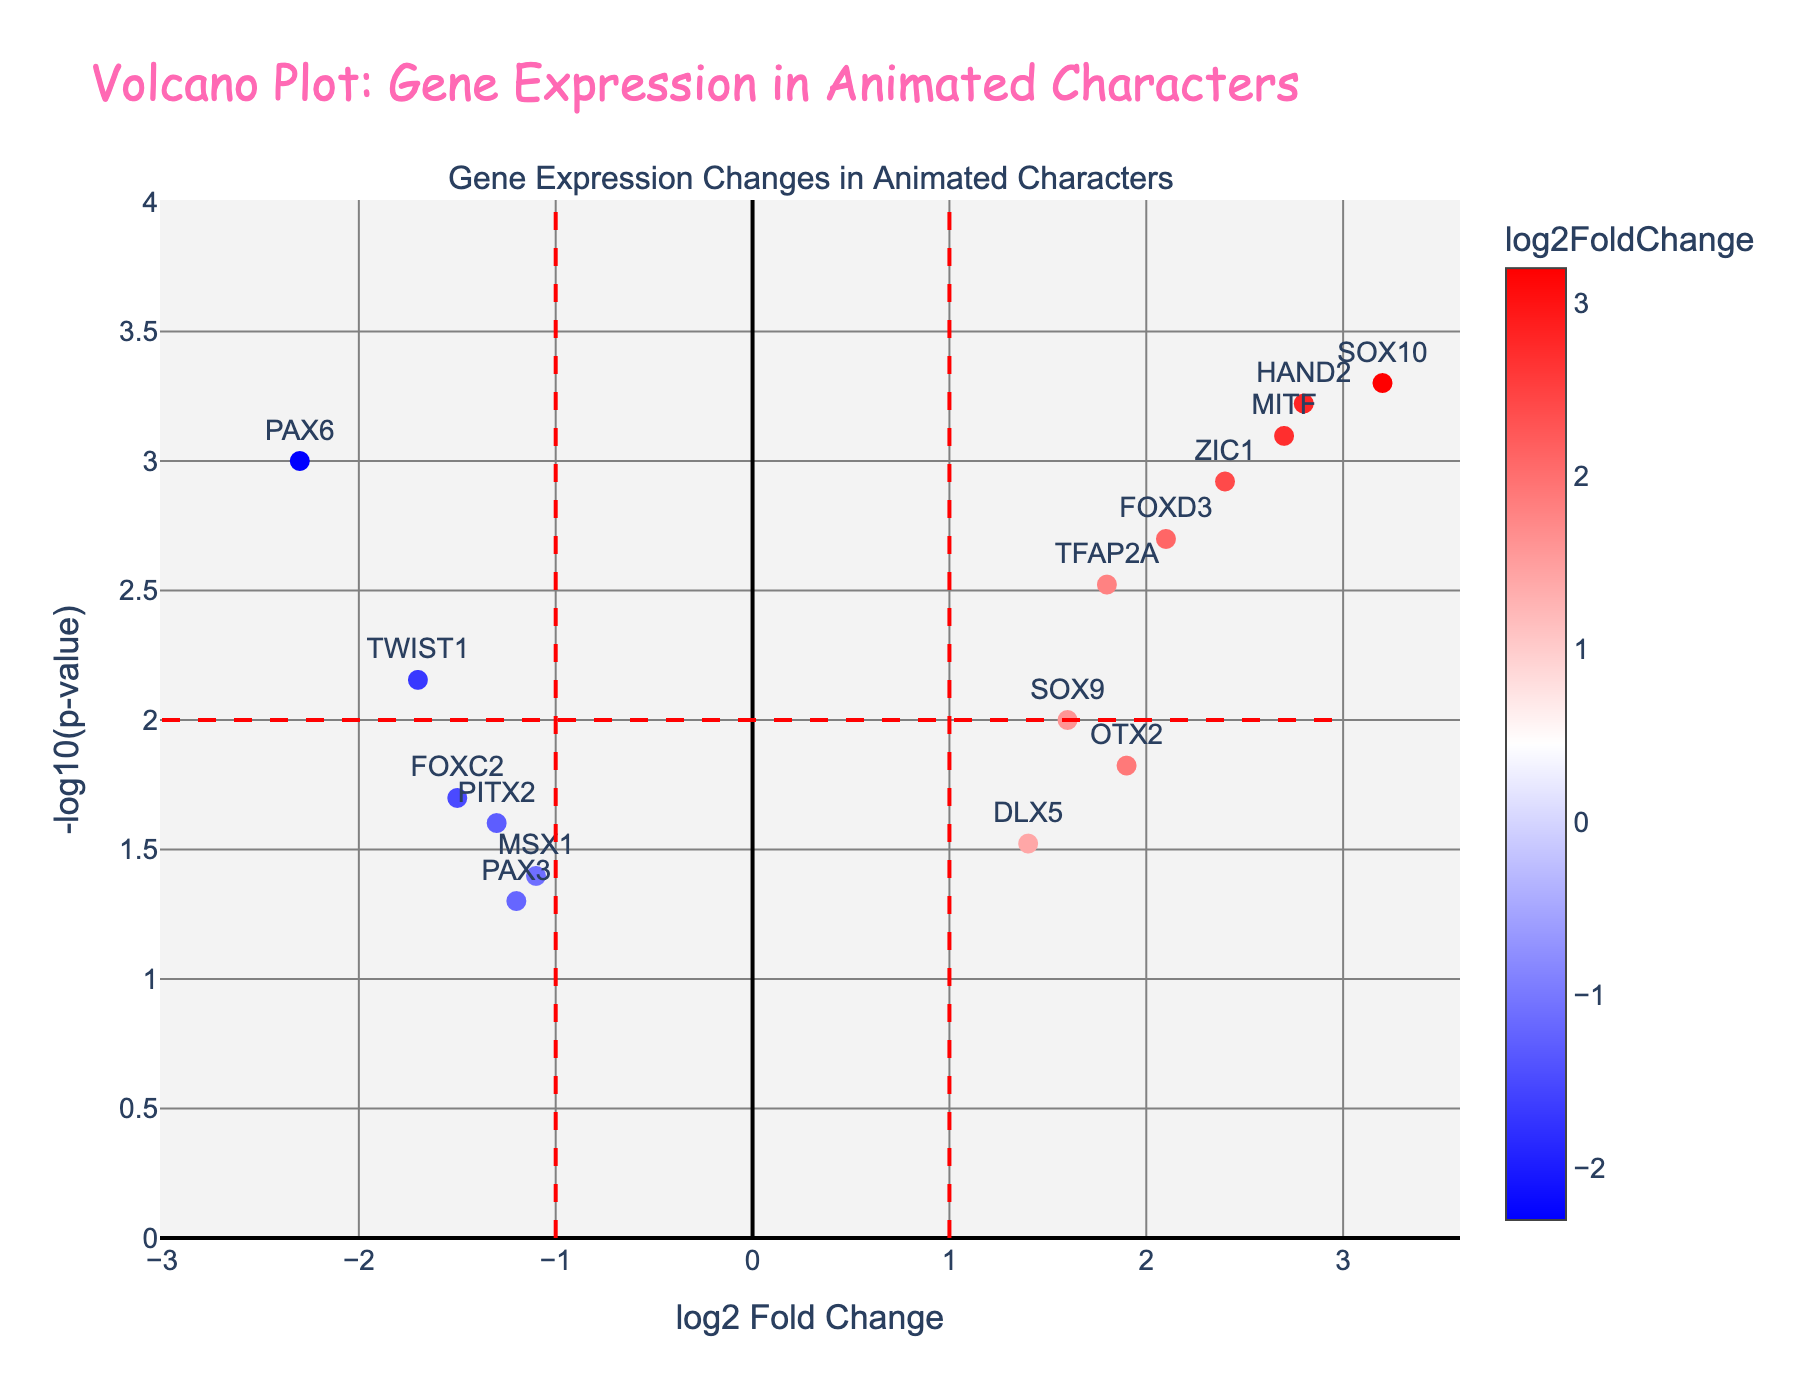What is the title of the plot? The title of the plot is located at the top of the figure and it reads "Volcano Plot: Gene Expression in Animated Characters".
Answer: Volcano Plot: Gene Expression in Animated Characters What does the x-axis represent? The x-axis of the plot represents the "log2 Fold Change". This indicates the logarithm base 2 of the fold change in gene expression.
Answer: log2 Fold Change What is represented on the y-axis? The y-axis of the plot represents "-log10(p-value)". This indicates the negative logarithm base 10 of the p-value.
Answer: -log10(p-value) Which gene is most significantly upregulated? To find the most significantly upregulated gene, look for the gene with the highest combination of log2 Fold Change (positive) and -log10(p-value). SOX10 has the highest values in these areas.
Answer: SOX10 How many genes have a log2 Fold Change greater than 2? Count the number of genes with a log2 Fold Change greater than 2. There are four such genes: SOX10, MITF, HAND2, and ZIC1.
Answer: 4 What are the log2 Fold Change and p-value for PAX6? Look at the data point labeled PAX6. Check its position on the x-axis and the hover text. The log2 Fold Change is -2.3 and the p-value is 0.001.
Answer: log2 Fold Change: -2.3, p-value: 0.001 Which gene has a log2 Fold Change closest to 0 but is still statistically significant (p-value < 0.05)? Check the genes with log2 Fold Change close to 0 and p-value < 0.05. DLX5 has a log2 Fold Change of 1.4 and p-value of 0.03.
Answer: DLX5 How many genes have a p-value less than or equal to 0.01? Identify the genes with p-value ≤ 0.01. There are six: PAX6, TFAP2A, SOX10, MITF, FOXD3, and TWIST1.
Answer: 6 What is the threshold line value for log2 Fold Change? The threshold lines for log2 Fold Change are drawn at -1 and 1 on the x-axis.
Answer: -1 and 1 What is the threshold line value for p-value? The threshold line value for p-value on the y-axis is drawn at -log10(p-value) = 2, which corresponds to a p-value of 0.01.
Answer: 2 